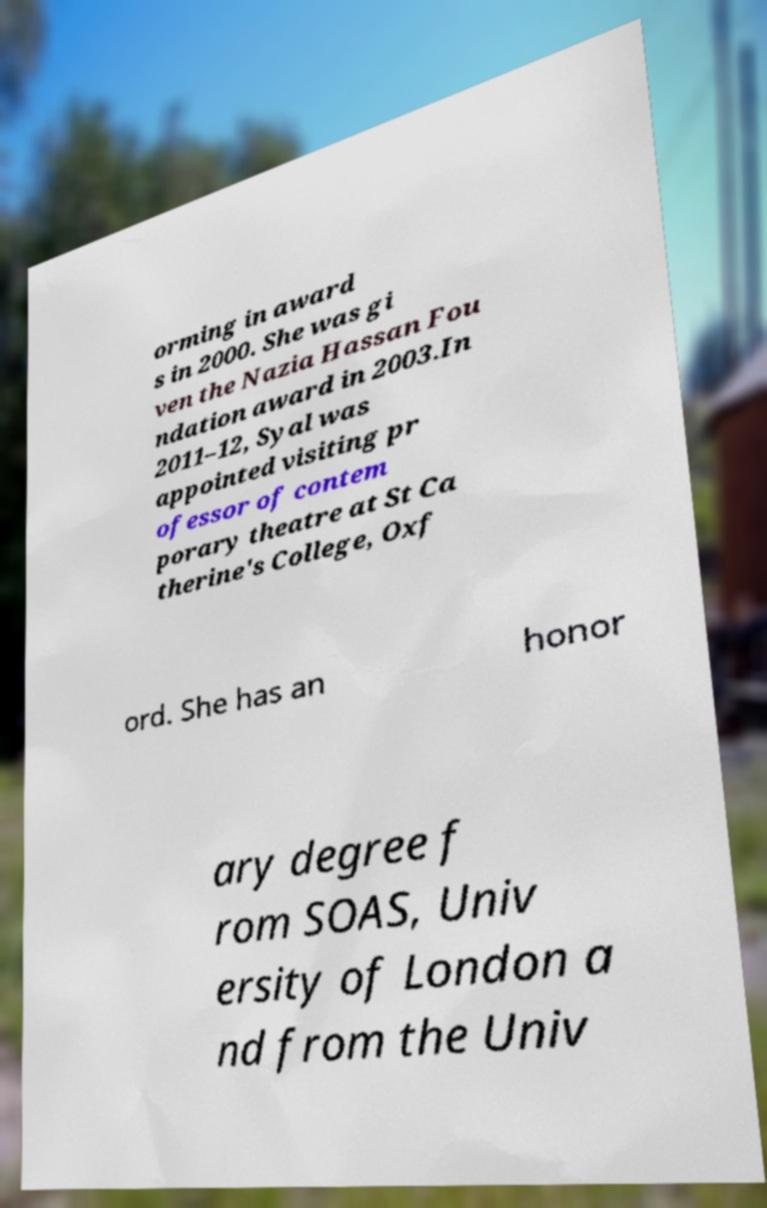There's text embedded in this image that I need extracted. Can you transcribe it verbatim? orming in award s in 2000. She was gi ven the Nazia Hassan Fou ndation award in 2003.In 2011–12, Syal was appointed visiting pr ofessor of contem porary theatre at St Ca therine's College, Oxf ord. She has an honor ary degree f rom SOAS, Univ ersity of London a nd from the Univ 